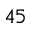Convert formula to latex. <formula><loc_0><loc_0><loc_500><loc_500>4 5</formula> 